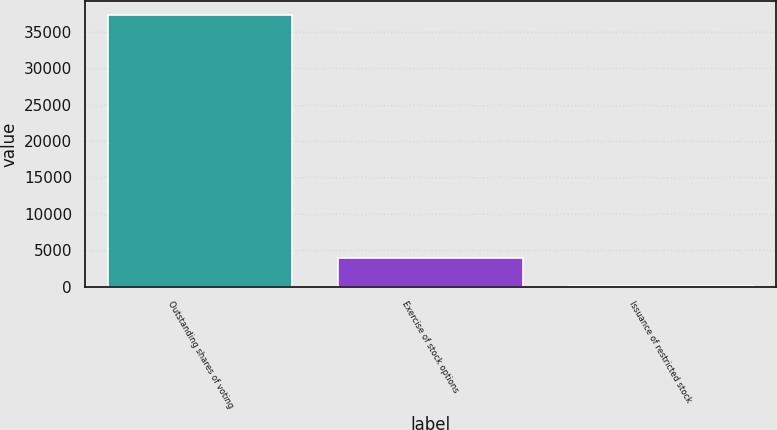Convert chart. <chart><loc_0><loc_0><loc_500><loc_500><bar_chart><fcel>Outstanding shares of voting<fcel>Exercise of stock options<fcel>Issuance of restricted stock<nl><fcel>37319<fcel>3877.3<fcel>116<nl></chart> 